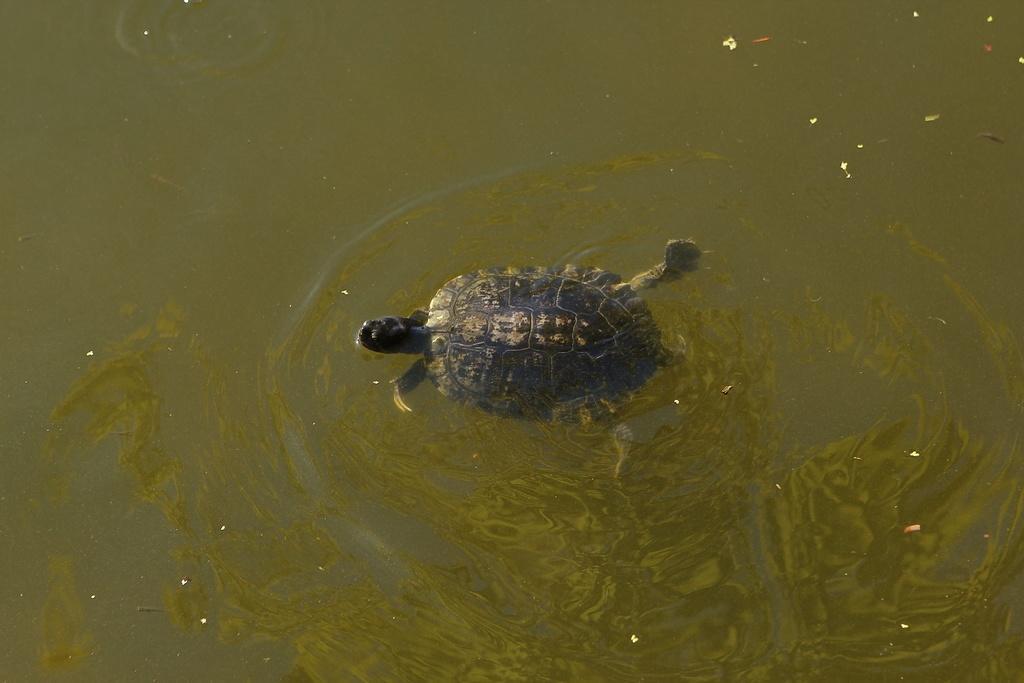Could you give a brief overview of what you see in this image? In this image I see a tortoise which is in the water. 